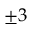Convert formula to latex. <formula><loc_0><loc_0><loc_500><loc_500>\pm 3</formula> 